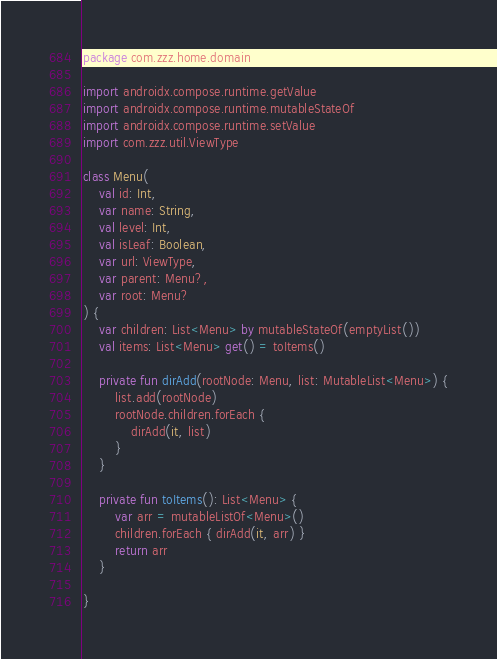Convert code to text. <code><loc_0><loc_0><loc_500><loc_500><_Kotlin_>package com.zzz.home.domain

import androidx.compose.runtime.getValue
import androidx.compose.runtime.mutableStateOf
import androidx.compose.runtime.setValue
import com.zzz.util.ViewType

class Menu(
    val id: Int,
    var name: String,
    val level: Int,
    val isLeaf: Boolean,
    var url: ViewType,
    var parent: Menu?,
    var root: Menu?
) {
    var children: List<Menu> by mutableStateOf(emptyList())
    val items: List<Menu> get() = toItems()

    private fun dirAdd(rootNode: Menu, list: MutableList<Menu>) {
        list.add(rootNode)
        rootNode.children.forEach {
            dirAdd(it, list)
        }
    }

    private fun toItems(): List<Menu> {
        var arr = mutableListOf<Menu>()
        children.forEach { dirAdd(it, arr) }
        return arr
    }

}</code> 